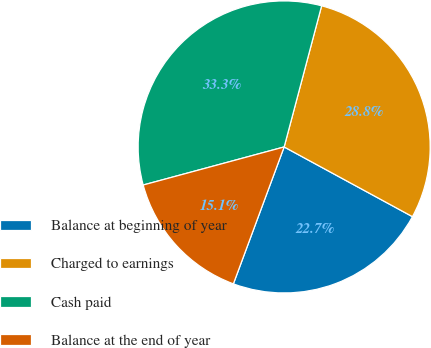Convert chart to OTSL. <chart><loc_0><loc_0><loc_500><loc_500><pie_chart><fcel>Balance at beginning of year<fcel>Charged to earnings<fcel>Cash paid<fcel>Balance at the end of year<nl><fcel>22.73%<fcel>28.79%<fcel>33.33%<fcel>15.15%<nl></chart> 